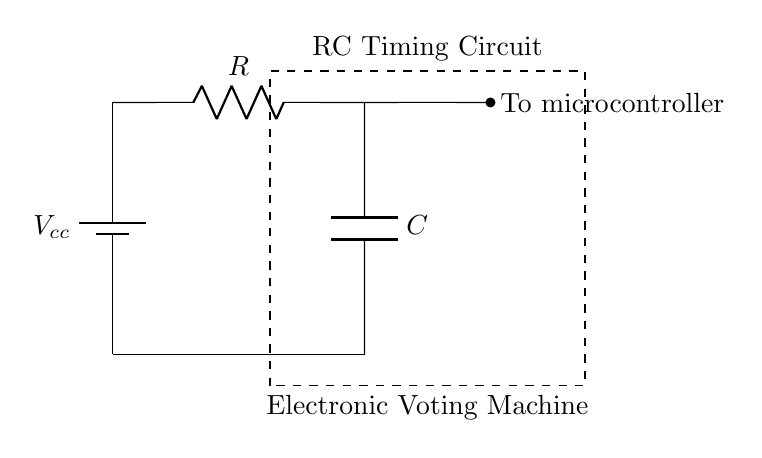What is the voltage source in this circuit? The voltage source in the circuit is represented by the battery, which is labeled as Vcc. It provides the necessary potential difference for the circuit to operate.
Answer: Vcc What are the two main components of the RC timing circuit? The two main components of the RC timing circuit are the resistor (labeled R) and the capacitor (labeled C). These components are crucial for creating the timing functionality in the circuit.
Answer: R and C Where does the output of the RC circuit connect? The output of the RC circuit connects to the microcontroller, as indicated by the text stating "To microcontroller" adjacent to the connection point. This shows where the timing signal is transmitted.
Answer: To microcontroller What is the function of the resistor in this circuit? The function of the resistor in this circuit is to limit the current flowing through the capacitor, which influences the charging and discharging times that affect the timing behavior of the circuit.
Answer: Limit current How does the capacitor affect timing in this circuit? The capacitor affects timing by charging and discharging through the resistor, creating a time constant which is the product of the resistance and capacitance (R*C). This determines how long it takes to charge to a certain voltage level, resulting in a specific timing interval for the electronic voting machine.
Answer: R*C What circuit type is represented by this configuration? The circuit type represented by this configuration is an RC circuit, which is specifically designed to utilize a resistor and capacitor for timing applications, commonly used in circuits needing delay functions.
Answer: RC circuit 